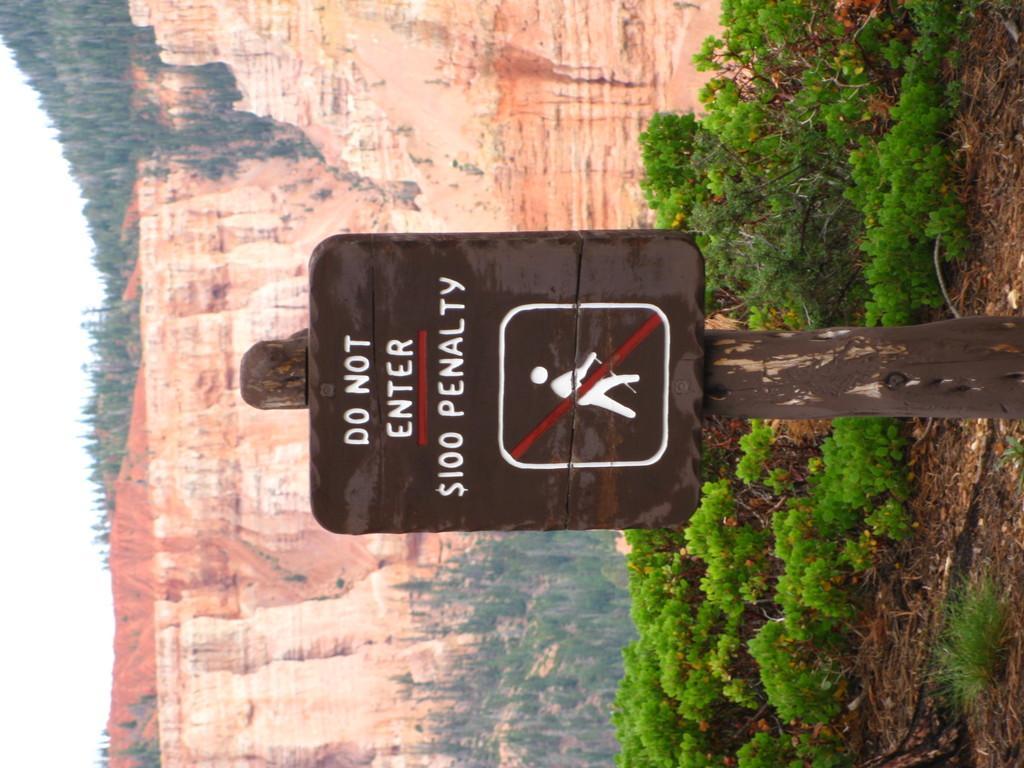Can you describe this image briefly? In this picture we can see a sign board attached to a pole, plants, trees, mountains and in the background we can see the sky. 